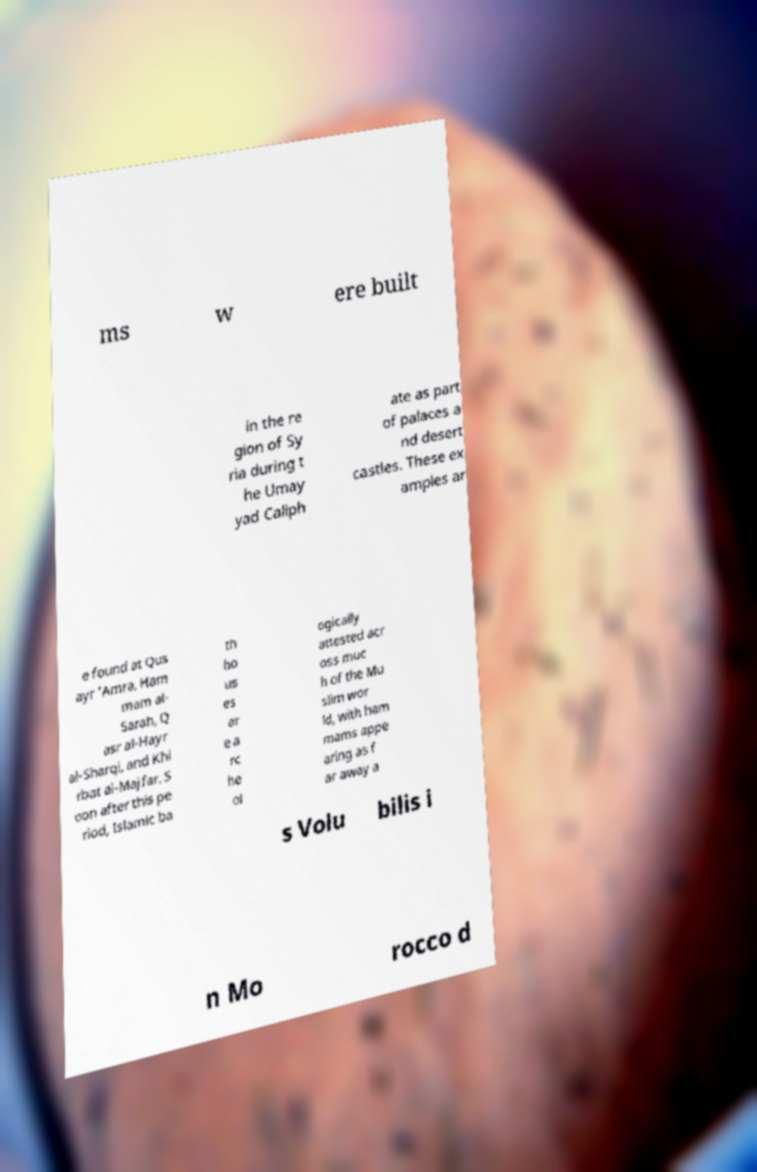I need the written content from this picture converted into text. Can you do that? ms w ere built in the re gion of Sy ria during t he Umay yad Caliph ate as part of palaces a nd desert castles. These ex amples ar e found at Qus ayr 'Amra, Ham mam al- Sarah, Q asr al-Hayr al-Sharqi, and Khi rbat al-Majfar. S oon after this pe riod, Islamic ba th ho us es ar e a rc he ol ogically attested acr oss muc h of the Mu slim wor ld, with ham mams appe aring as f ar away a s Volu bilis i n Mo rocco d 